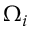Convert formula to latex. <formula><loc_0><loc_0><loc_500><loc_500>\Omega _ { i }</formula> 